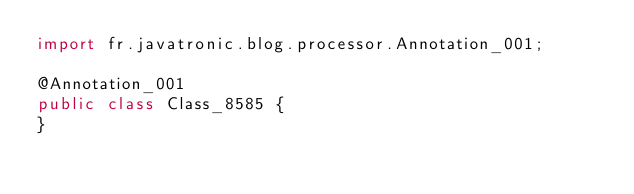Convert code to text. <code><loc_0><loc_0><loc_500><loc_500><_Java_>import fr.javatronic.blog.processor.Annotation_001;

@Annotation_001
public class Class_8585 {
}
</code> 